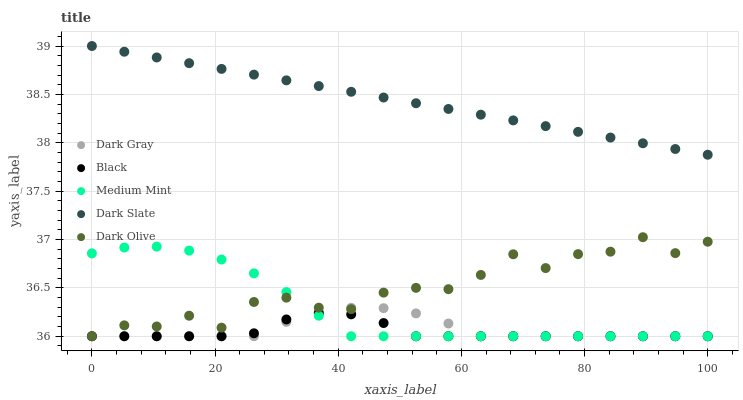Does Black have the minimum area under the curve?
Answer yes or no. Yes. Does Dark Slate have the maximum area under the curve?
Answer yes or no. Yes. Does Medium Mint have the minimum area under the curve?
Answer yes or no. No. Does Medium Mint have the maximum area under the curve?
Answer yes or no. No. Is Dark Slate the smoothest?
Answer yes or no. Yes. Is Dark Olive the roughest?
Answer yes or no. Yes. Is Medium Mint the smoothest?
Answer yes or no. No. Is Medium Mint the roughest?
Answer yes or no. No. Does Dark Gray have the lowest value?
Answer yes or no. Yes. Does Dark Slate have the lowest value?
Answer yes or no. No. Does Dark Slate have the highest value?
Answer yes or no. Yes. Does Medium Mint have the highest value?
Answer yes or no. No. Is Dark Gray less than Dark Slate?
Answer yes or no. Yes. Is Dark Slate greater than Dark Gray?
Answer yes or no. Yes. Does Black intersect Medium Mint?
Answer yes or no. Yes. Is Black less than Medium Mint?
Answer yes or no. No. Is Black greater than Medium Mint?
Answer yes or no. No. Does Dark Gray intersect Dark Slate?
Answer yes or no. No. 